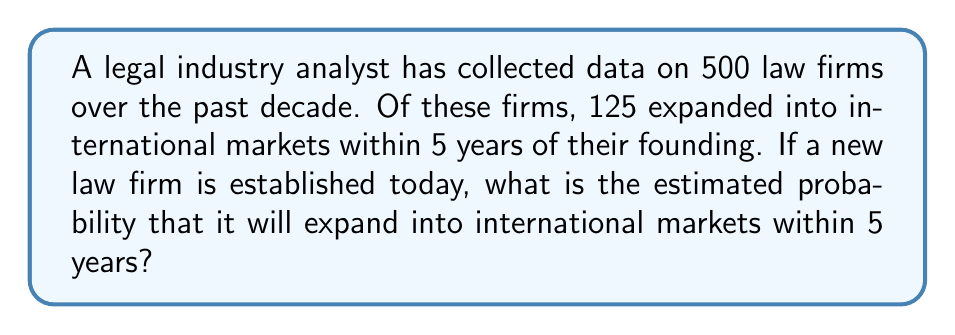Show me your answer to this math problem. To solve this problem, we'll use the concept of relative frequency as an estimate of probability. Here's a step-by-step explanation:

1. Identify the total number of law firms in the sample:
   $n = 500$

2. Identify the number of law firms that expanded internationally within 5 years:
   $x = 125$

3. Calculate the relative frequency:
   The probability is estimated by dividing the number of successful events by the total number of events.

   $P(\text{expansion}) = \frac{x}{n} = \frac{125}{500}$

4. Simplify the fraction:
   $\frac{125}{500} = \frac{1}{4} = 0.25$

5. Convert to a percentage:
   $0.25 \times 100\% = 25\%$

Therefore, based on the historical data, we estimate that a new law firm has a 25% probability of expanding into international markets within 5 years.
Answer: 25% 